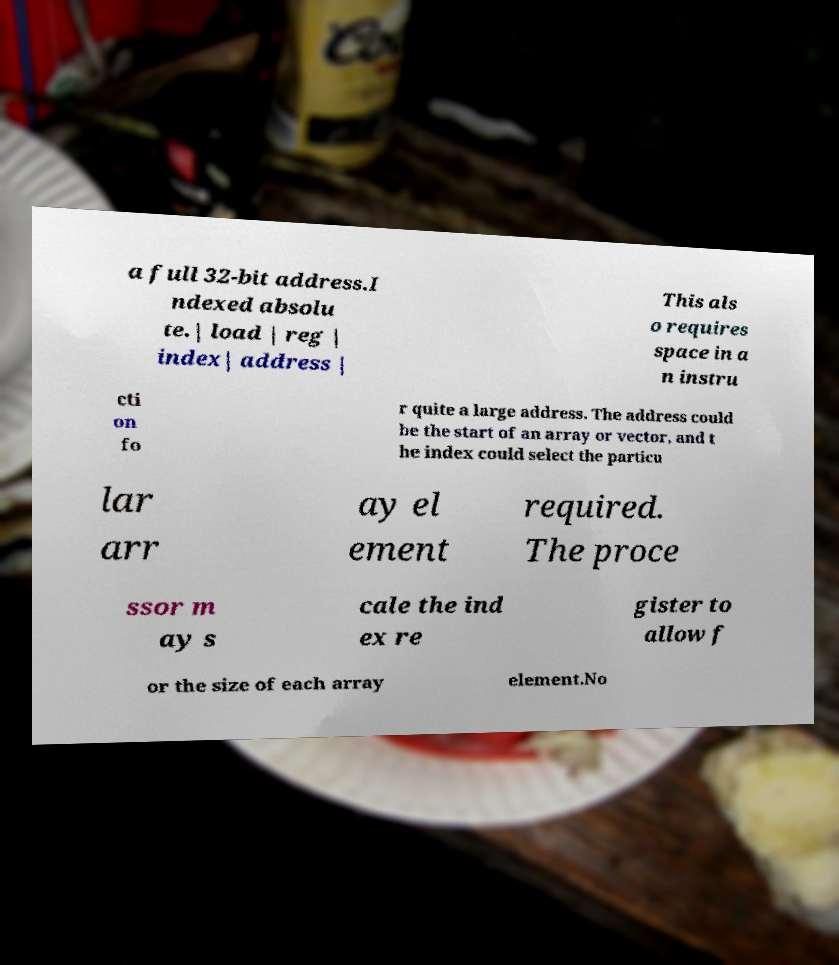What messages or text are displayed in this image? I need them in a readable, typed format. a full 32-bit address.I ndexed absolu te.| load | reg | index| address | This als o requires space in a n instru cti on fo r quite a large address. The address could be the start of an array or vector, and t he index could select the particu lar arr ay el ement required. The proce ssor m ay s cale the ind ex re gister to allow f or the size of each array element.No 